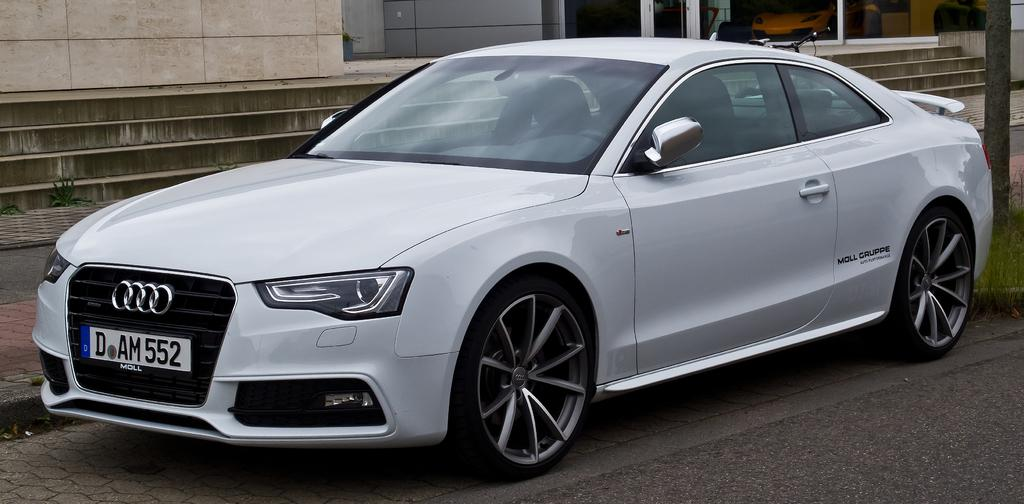What is the main subject of the image? There is a car on the road in the image. What can be seen in the background of the image? There is a building, stairs, and a bicycle visible in the background of the image. Can you describe any other objects in the image? There is a pole in the image. What language is spoken by the fowl in the image? There are no fowl present in the image, so it is not possible to determine what language they might speak. 